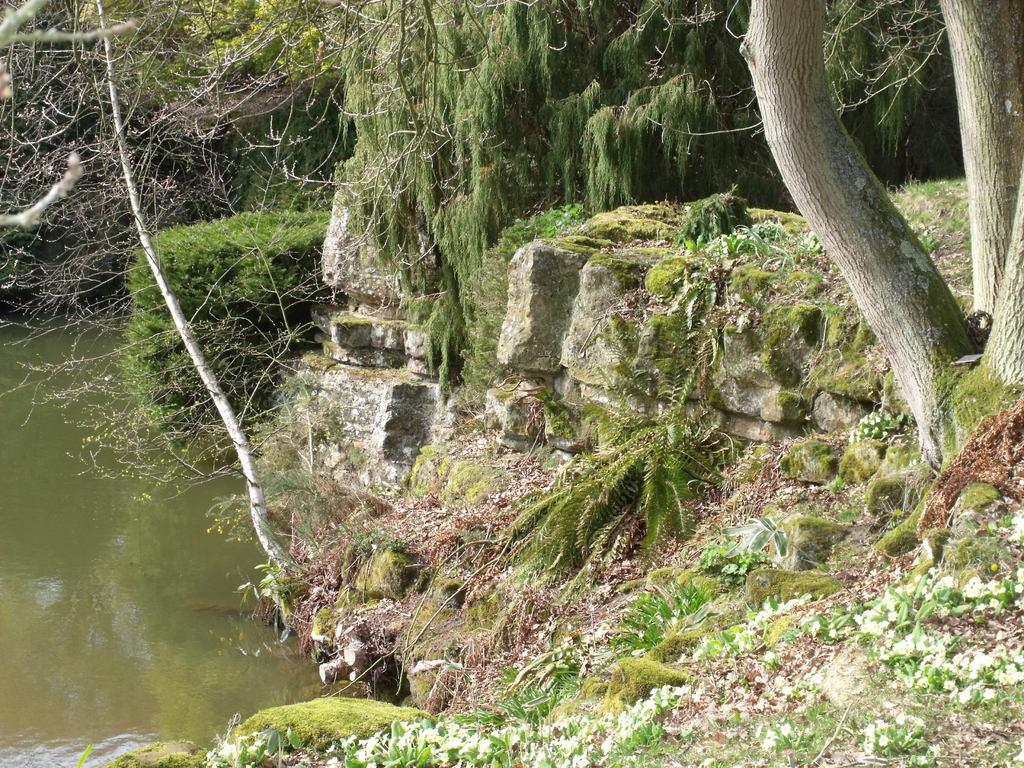What type of natural elements can be seen in the image? There are rocks, trees, and plants in the image. Where is the water located in the image? The water is on the left side of the image. Can you describe the intricate design of the cobweb in the image? There is no cobweb present in the image. 